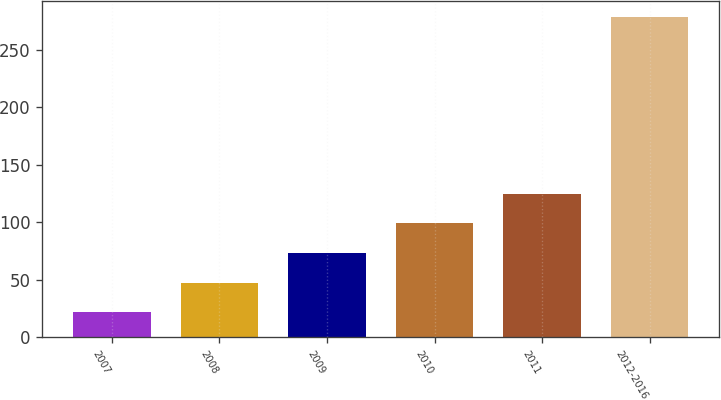Convert chart to OTSL. <chart><loc_0><loc_0><loc_500><loc_500><bar_chart><fcel>2007<fcel>2008<fcel>2009<fcel>2010<fcel>2011<fcel>2012-2016<nl><fcel>22<fcel>47.7<fcel>73.4<fcel>99.1<fcel>124.8<fcel>279<nl></chart> 